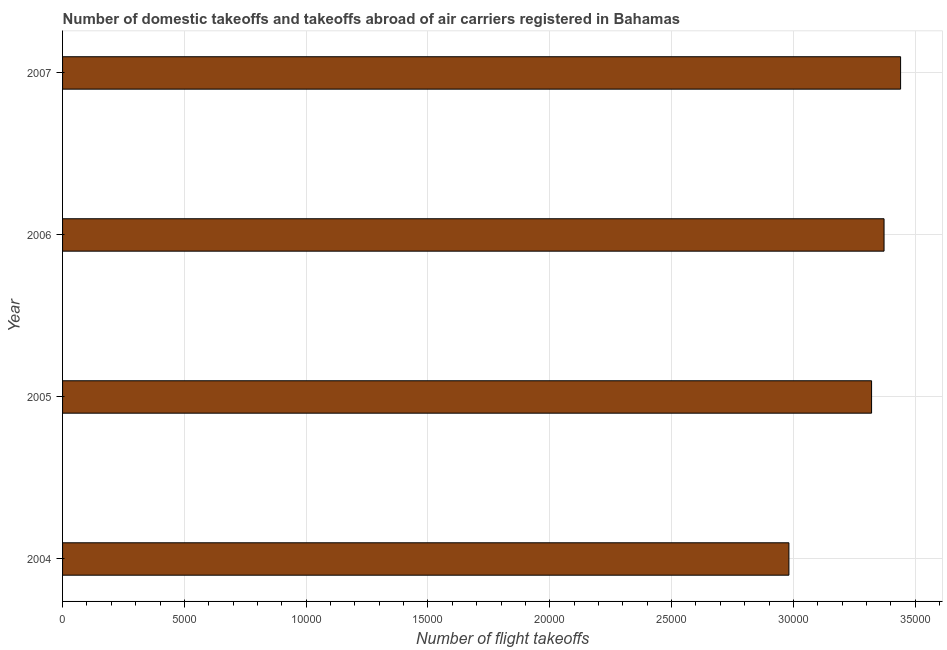Does the graph contain any zero values?
Offer a terse response. No. Does the graph contain grids?
Make the answer very short. Yes. What is the title of the graph?
Offer a terse response. Number of domestic takeoffs and takeoffs abroad of air carriers registered in Bahamas. What is the label or title of the X-axis?
Your answer should be very brief. Number of flight takeoffs. What is the number of flight takeoffs in 2005?
Offer a terse response. 3.32e+04. Across all years, what is the maximum number of flight takeoffs?
Offer a very short reply. 3.44e+04. Across all years, what is the minimum number of flight takeoffs?
Provide a short and direct response. 2.98e+04. In which year was the number of flight takeoffs maximum?
Provide a succinct answer. 2007. What is the sum of the number of flight takeoffs?
Give a very brief answer. 1.31e+05. What is the difference between the number of flight takeoffs in 2005 and 2006?
Give a very brief answer. -512. What is the average number of flight takeoffs per year?
Your response must be concise. 3.28e+04. What is the median number of flight takeoffs?
Provide a short and direct response. 3.35e+04. In how many years, is the number of flight takeoffs greater than 13000 ?
Your answer should be compact. 4. Do a majority of the years between 2006 and 2005 (inclusive) have number of flight takeoffs greater than 17000 ?
Offer a terse response. No. What is the ratio of the number of flight takeoffs in 2004 to that in 2005?
Provide a short and direct response. 0.9. Is the number of flight takeoffs in 2006 less than that in 2007?
Give a very brief answer. Yes. What is the difference between the highest and the second highest number of flight takeoffs?
Your answer should be very brief. 679. What is the difference between the highest and the lowest number of flight takeoffs?
Provide a succinct answer. 4585. Are all the bars in the graph horizontal?
Keep it short and to the point. Yes. How many years are there in the graph?
Offer a terse response. 4. What is the difference between two consecutive major ticks on the X-axis?
Give a very brief answer. 5000. What is the Number of flight takeoffs of 2004?
Keep it short and to the point. 2.98e+04. What is the Number of flight takeoffs in 2005?
Provide a short and direct response. 3.32e+04. What is the Number of flight takeoffs in 2006?
Your response must be concise. 3.37e+04. What is the Number of flight takeoffs of 2007?
Offer a terse response. 3.44e+04. What is the difference between the Number of flight takeoffs in 2004 and 2005?
Provide a short and direct response. -3394. What is the difference between the Number of flight takeoffs in 2004 and 2006?
Your response must be concise. -3906. What is the difference between the Number of flight takeoffs in 2004 and 2007?
Make the answer very short. -4585. What is the difference between the Number of flight takeoffs in 2005 and 2006?
Keep it short and to the point. -512. What is the difference between the Number of flight takeoffs in 2005 and 2007?
Your response must be concise. -1191. What is the difference between the Number of flight takeoffs in 2006 and 2007?
Make the answer very short. -679. What is the ratio of the Number of flight takeoffs in 2004 to that in 2005?
Keep it short and to the point. 0.9. What is the ratio of the Number of flight takeoffs in 2004 to that in 2006?
Offer a terse response. 0.88. What is the ratio of the Number of flight takeoffs in 2004 to that in 2007?
Keep it short and to the point. 0.87. What is the ratio of the Number of flight takeoffs in 2005 to that in 2007?
Provide a succinct answer. 0.96. What is the ratio of the Number of flight takeoffs in 2006 to that in 2007?
Make the answer very short. 0.98. 